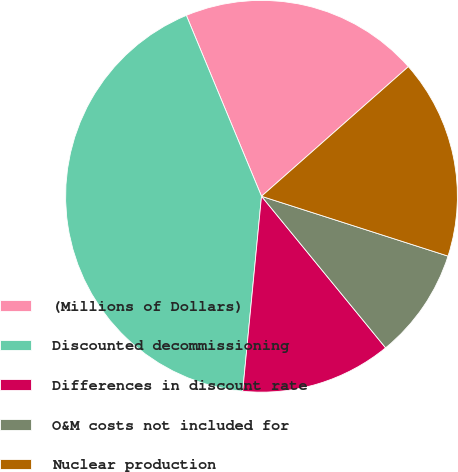Convert chart. <chart><loc_0><loc_0><loc_500><loc_500><pie_chart><fcel>(Millions of Dollars)<fcel>Discounted decommissioning<fcel>Differences in discount rate<fcel>O&M costs not included for<fcel>Nuclear production<nl><fcel>19.76%<fcel>42.2%<fcel>12.45%<fcel>9.14%<fcel>16.45%<nl></chart> 